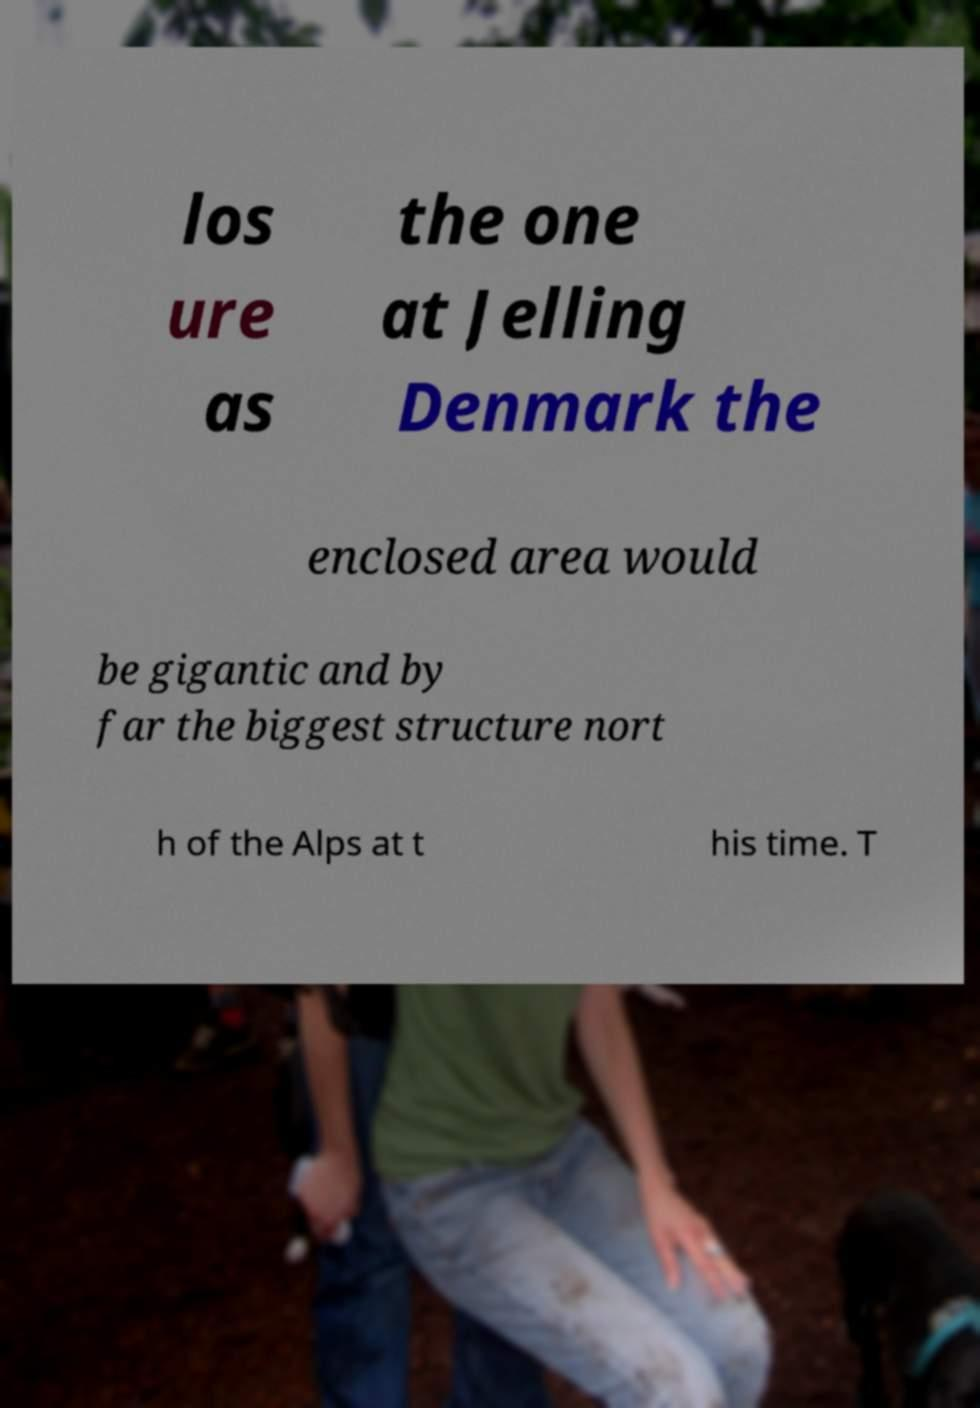What messages or text are displayed in this image? I need them in a readable, typed format. los ure as the one at Jelling Denmark the enclosed area would be gigantic and by far the biggest structure nort h of the Alps at t his time. T 